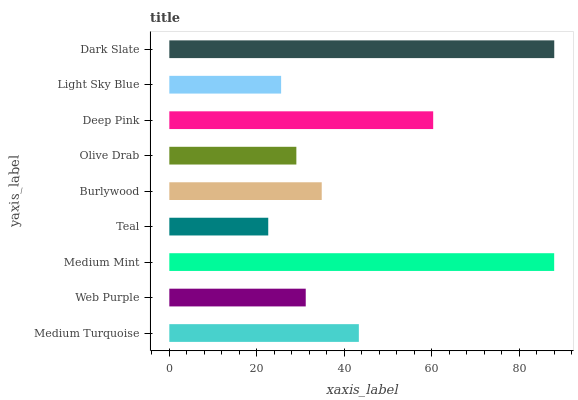Is Teal the minimum?
Answer yes or no. Yes. Is Dark Slate the maximum?
Answer yes or no. Yes. Is Web Purple the minimum?
Answer yes or no. No. Is Web Purple the maximum?
Answer yes or no. No. Is Medium Turquoise greater than Web Purple?
Answer yes or no. Yes. Is Web Purple less than Medium Turquoise?
Answer yes or no. Yes. Is Web Purple greater than Medium Turquoise?
Answer yes or no. No. Is Medium Turquoise less than Web Purple?
Answer yes or no. No. Is Burlywood the high median?
Answer yes or no. Yes. Is Burlywood the low median?
Answer yes or no. Yes. Is Dark Slate the high median?
Answer yes or no. No. Is Olive Drab the low median?
Answer yes or no. No. 